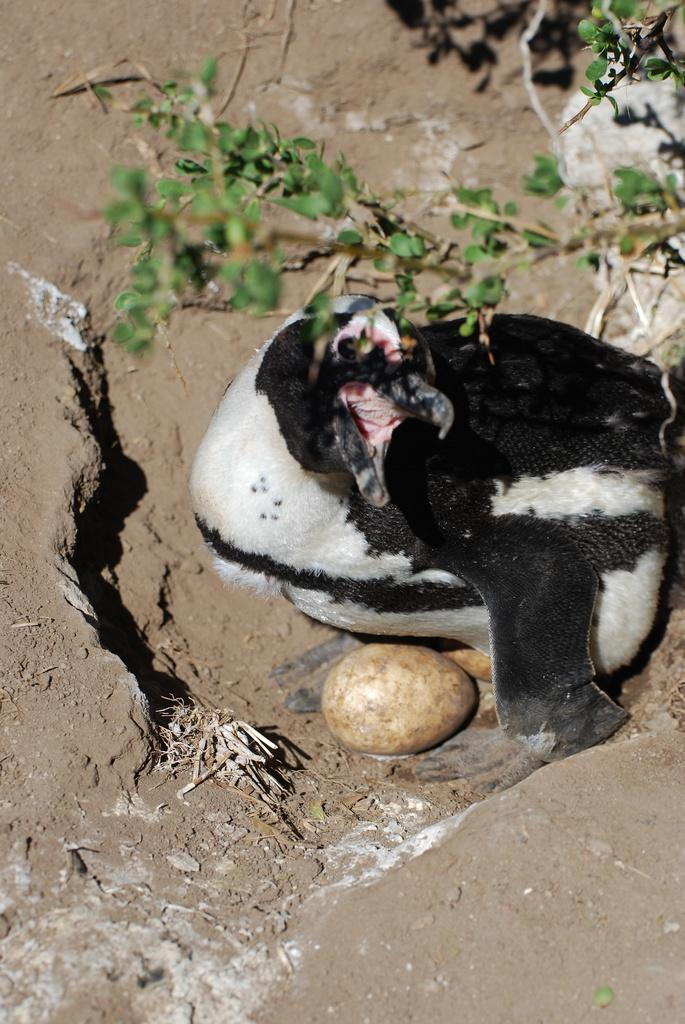Where was the picture taken? The picture was clicked outside. What can be seen on the ground in the image? There is a bird sitting on the ground, and there are eggs placed on the ground. What is visible in the background of the image? There are plants visible in the background. What team is responsible for folding the eggs in the image? There is no team present in the image, and the eggs are not being folded. 